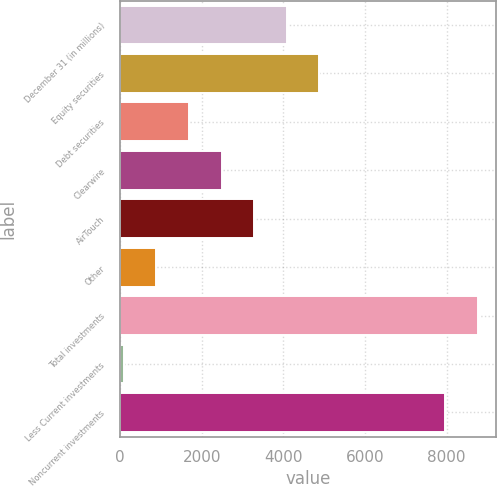<chart> <loc_0><loc_0><loc_500><loc_500><bar_chart><fcel>December 31 (in millions)<fcel>Equity securities<fcel>Debt securities<fcel>Clearwire<fcel>AirTouch<fcel>Other<fcel>Total investments<fcel>Less Current investments<fcel>Noncurrent investments<nl><fcel>4079.5<fcel>4875.8<fcel>1690.6<fcel>2486.9<fcel>3283.2<fcel>894.3<fcel>8759.3<fcel>98<fcel>7963<nl></chart> 